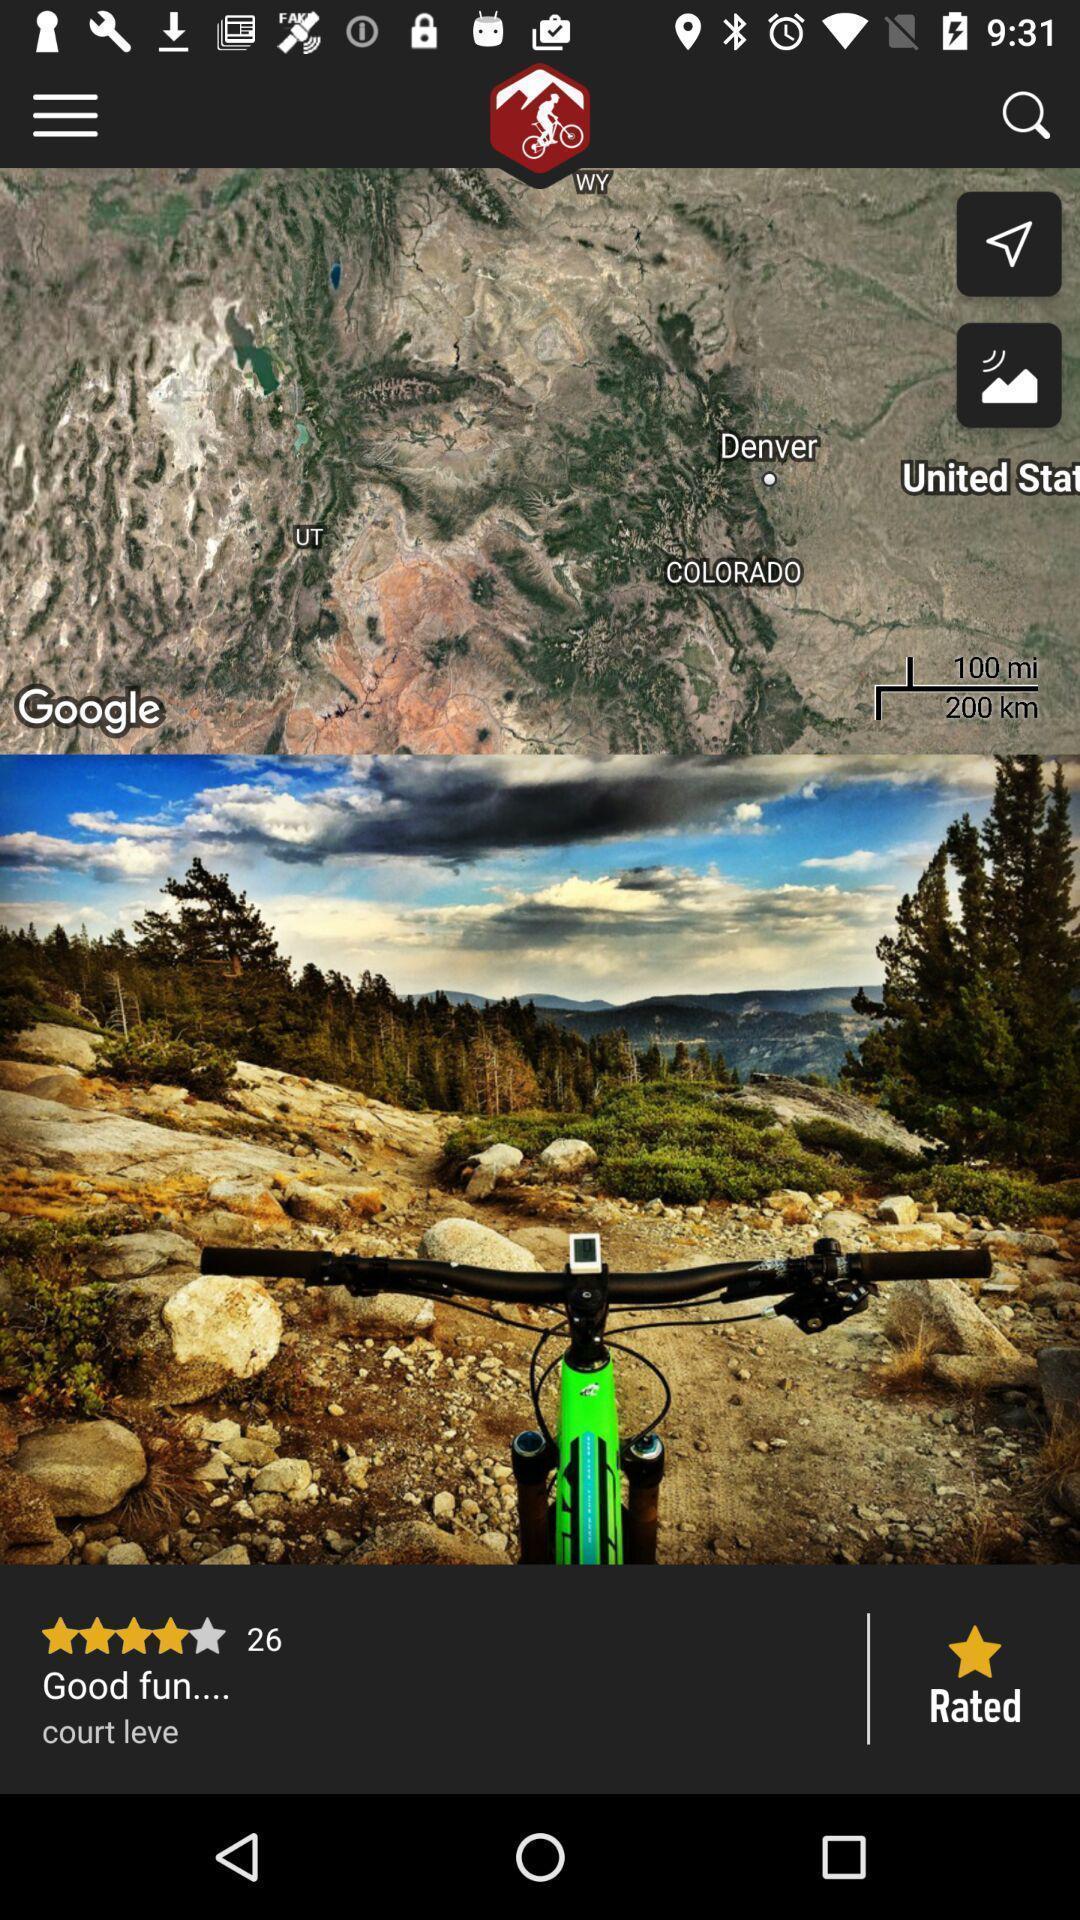Provide a description of this screenshot. Page showing about places on map. 